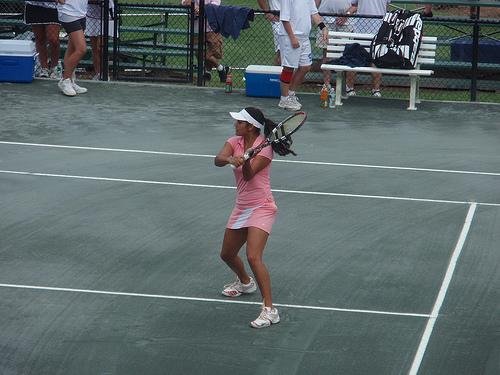Question: why is the woman holding a tennis racket?
Choices:
A. She is holding it for a friend.
B. Playing tennis.
C. She is carrying it to practice.
D. She is on her way home from practice.
Answer with the letter. Answer: B Question: where is the woman?
Choices:
A. On a tennis court.
B. On a basketball court.
C. In a hockey rink.
D. On a baseball field.
Answer with the letter. Answer: A Question: what is on the woman's head?
Choices:
A. A hat.
B. A headband.
C. Sunglasses.
D. A visor.
Answer with the letter. Answer: D Question: what is in the woman's hand?
Choices:
A. A tennis racket.
B. A hockey stick.
C. A basketball.
D. A baseball.
Answer with the letter. Answer: A Question: who is playing tennis?
Choices:
A. A man.
B. A child.
C. A teenager.
D. A woman.
Answer with the letter. Answer: D 